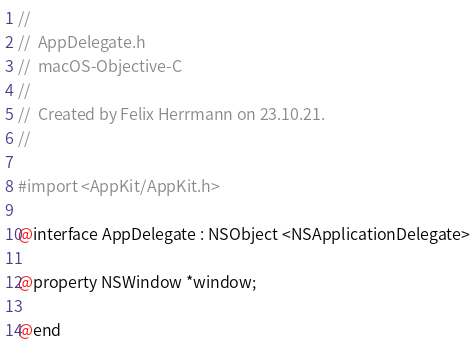Convert code to text. <code><loc_0><loc_0><loc_500><loc_500><_C_>//
//  AppDelegate.h
//  macOS-Objective-C
//
//  Created by Felix Herrmann on 23.10.21.
//

#import <AppKit/AppKit.h>

@interface AppDelegate : NSObject <NSApplicationDelegate>

@property NSWindow *window;

@end
</code> 